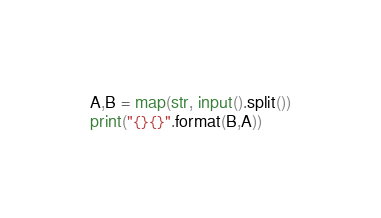<code> <loc_0><loc_0><loc_500><loc_500><_Python_>A,B = map(str, input().split())
print("{}{}".format(B,A))</code> 